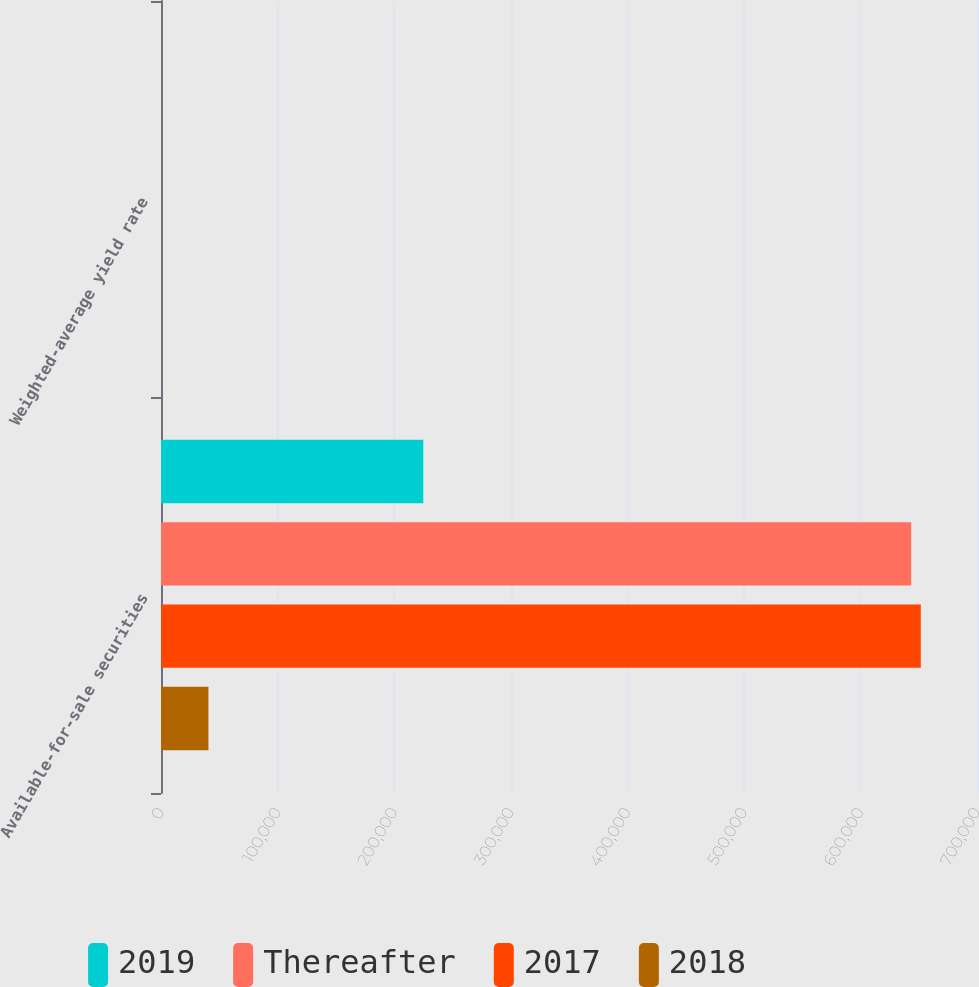Convert chart to OTSL. <chart><loc_0><loc_0><loc_500><loc_500><stacked_bar_chart><ecel><fcel>Available-for-sale securities<fcel>Weighted-average yield rate<nl><fcel>2019<fcel>225009<fcel>0.91<nl><fcel>Thereafter<fcel>643508<fcel>1.03<nl><fcel>2017<fcel>651795<fcel>1.24<nl><fcel>2018<fcel>40687<fcel>1.55<nl></chart> 